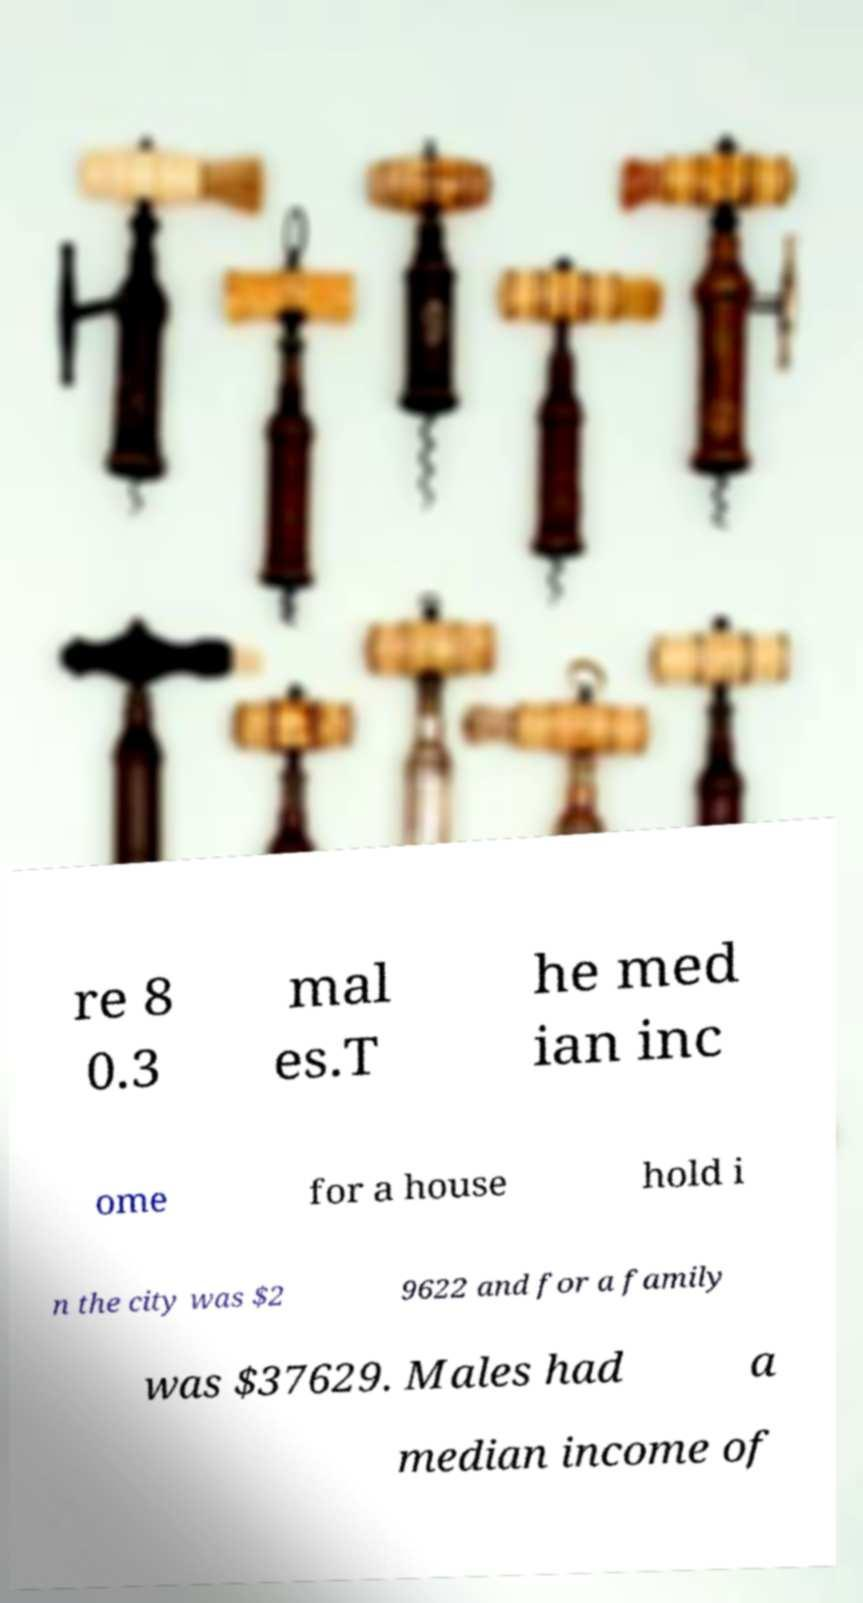For documentation purposes, I need the text within this image transcribed. Could you provide that? re 8 0.3 mal es.T he med ian inc ome for a house hold i n the city was $2 9622 and for a family was $37629. Males had a median income of 